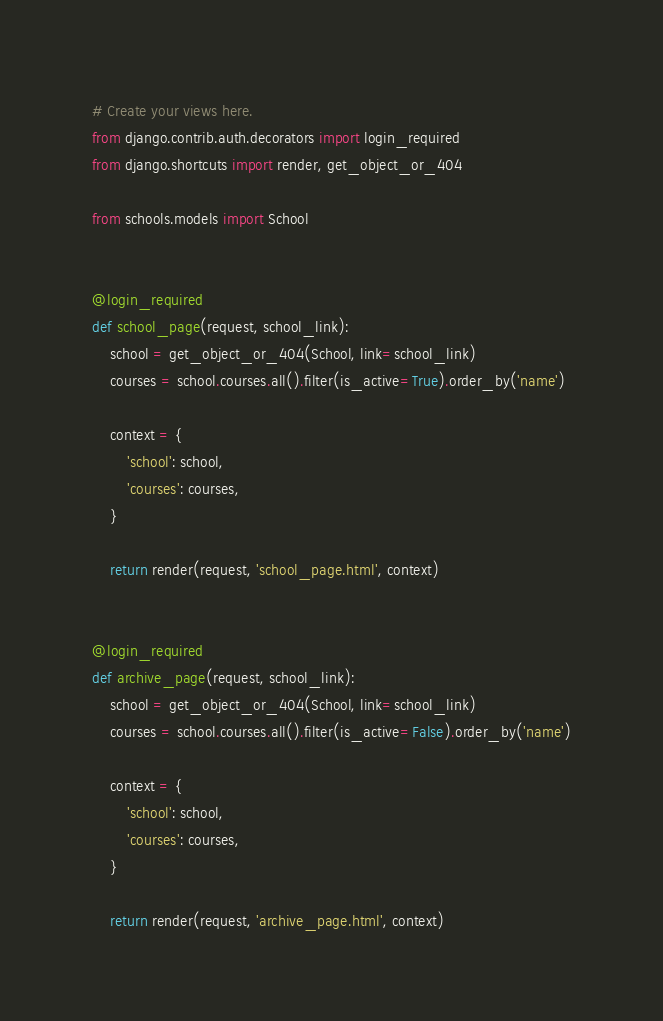Convert code to text. <code><loc_0><loc_0><loc_500><loc_500><_Python_># Create your views here.
from django.contrib.auth.decorators import login_required
from django.shortcuts import render, get_object_or_404

from schools.models import School


@login_required
def school_page(request, school_link):
    school = get_object_or_404(School, link=school_link)
    courses = school.courses.all().filter(is_active=True).order_by('name')

    context = {
        'school': school,
        'courses': courses,
    }

    return render(request, 'school_page.html', context)


@login_required
def archive_page(request, school_link):
    school = get_object_or_404(School, link=school_link)
    courses = school.courses.all().filter(is_active=False).order_by('name')

    context = {
        'school': school,
        'courses': courses,
    }

    return render(request, 'archive_page.html', context)
</code> 